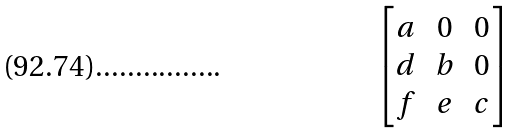<formula> <loc_0><loc_0><loc_500><loc_500>\begin{bmatrix} a & 0 & 0 \\ d & b & 0 \\ f & e & c \end{bmatrix}</formula> 